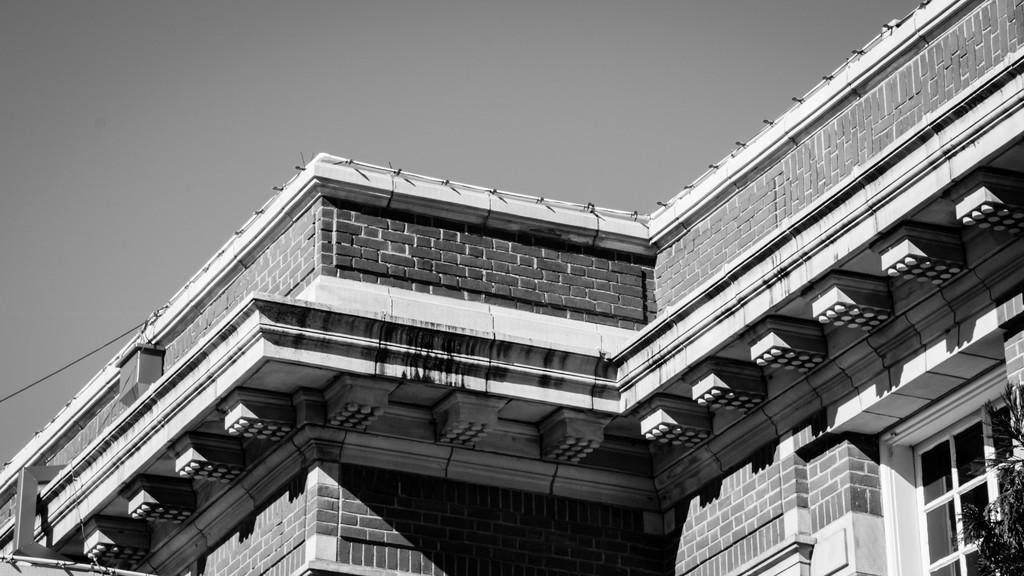Could you give a brief overview of what you see in this image? In the image we can see black and white picture of the building and the windows of the building. We can even see the leaves, electric wire and the sky. 